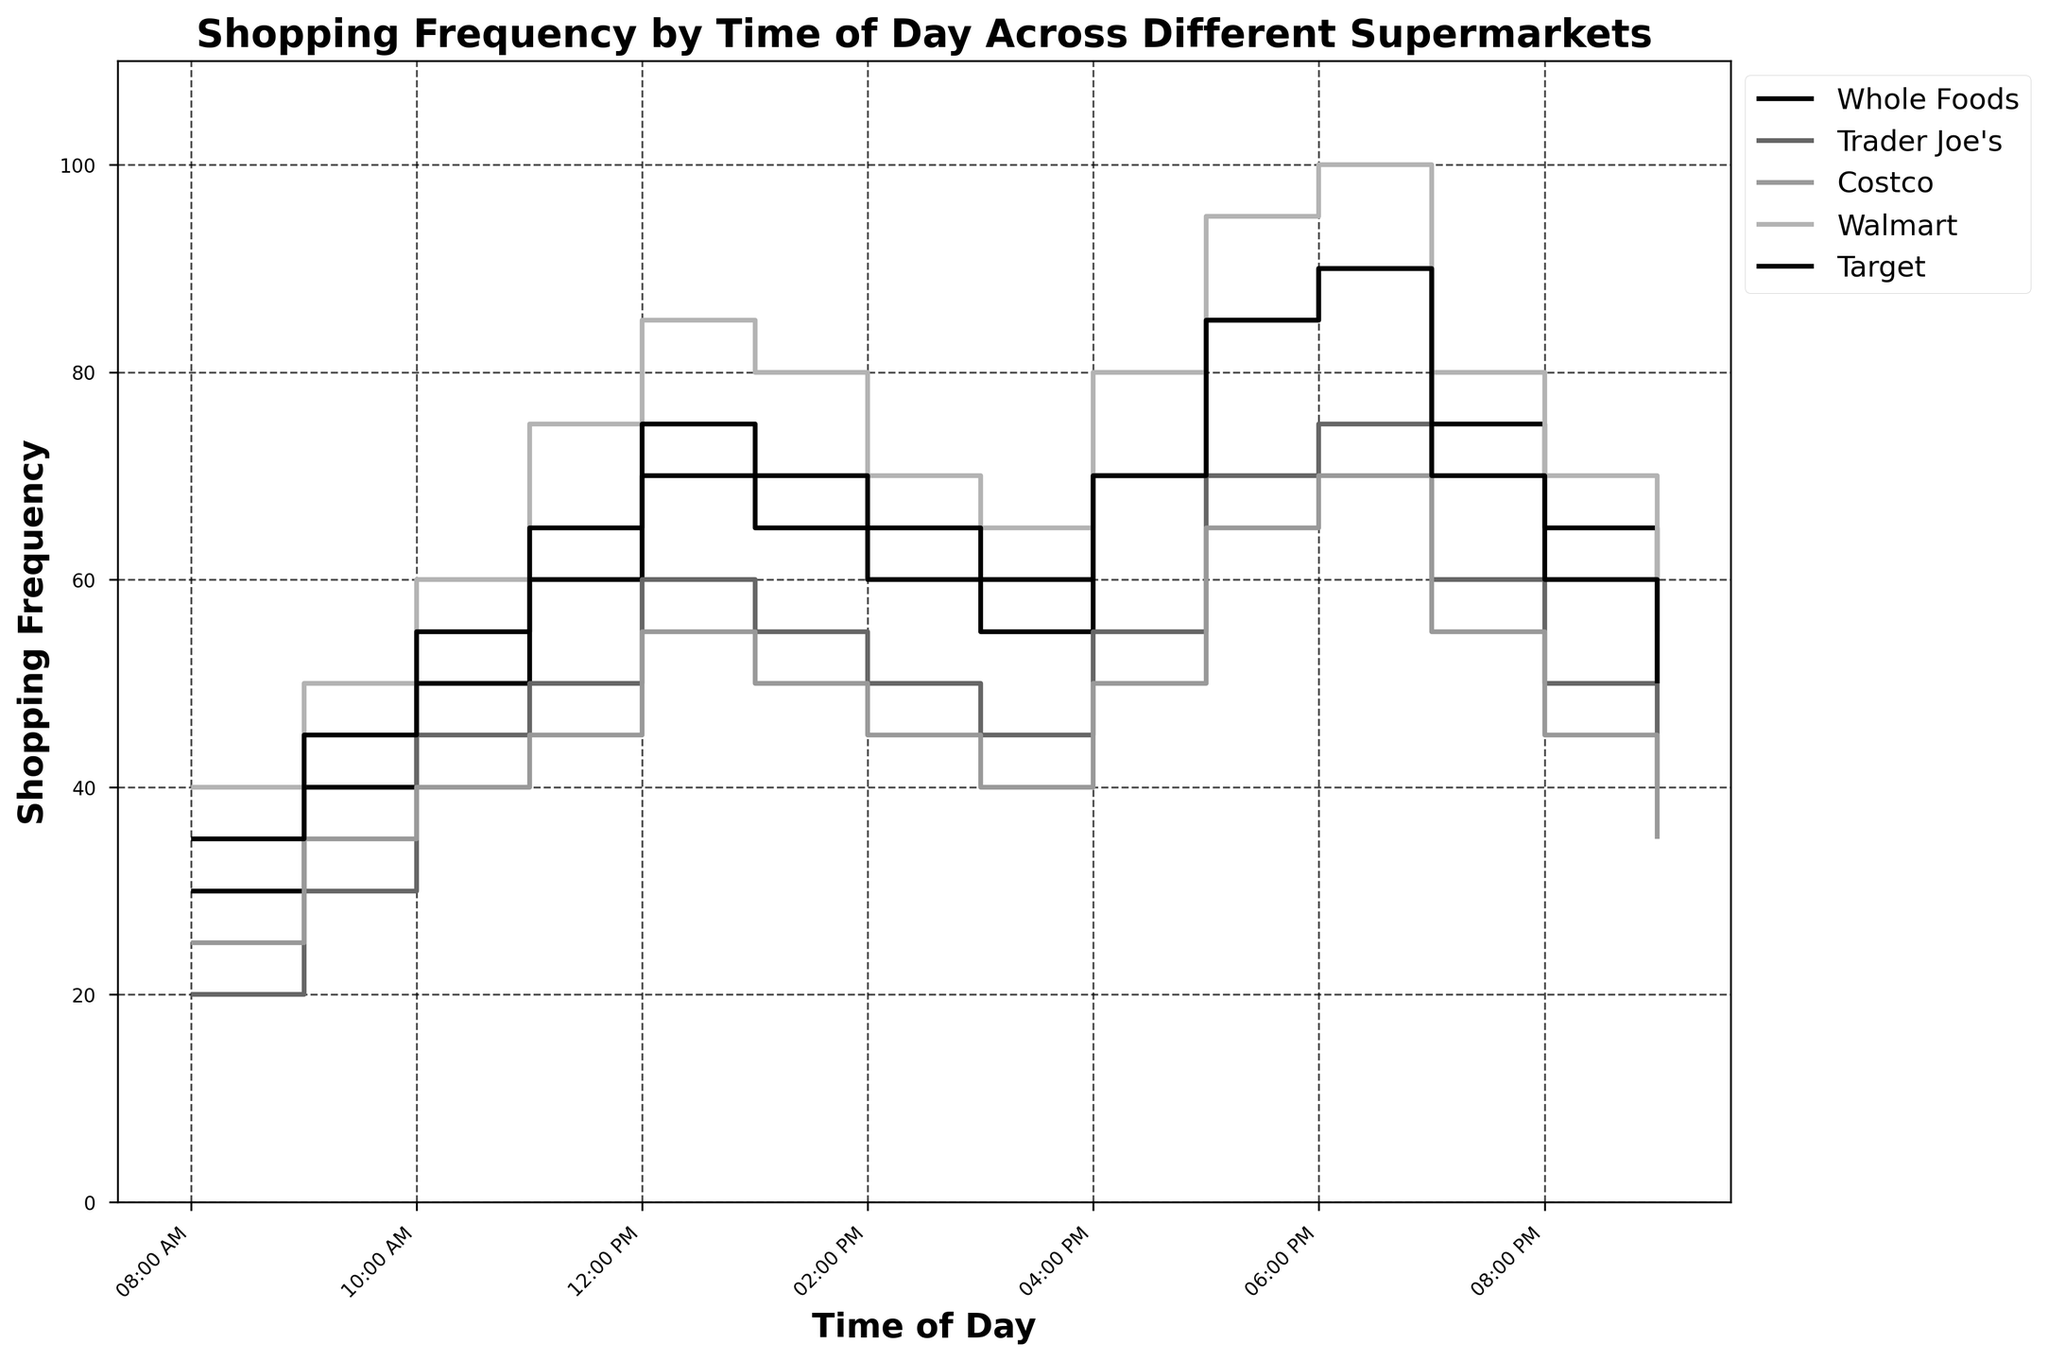What is the title of the figure? The title is located at the top of the figure. It is bold and larger in font size compared to other texts in the figure.
Answer: Shopping Frequency by Time of Day Across Different Supermarkets Which supermarket has the highest shopping frequency at 6:00 PM? Look at the vertical level corresponding to 6:00 PM on the x-axis. Identify which line (corresponding to a supermarket) is at the highest vertical position. This represents the highest frequency.
Answer: Walmart How many times does the shopping frequency at Trader Joe’s exceed 50? Look at the Trader Joe's line and count the number of points where the vertical level (y-axis) exceeds 50.
Answer: 4 times At what time does Whole Foods' shopping frequency peak? Examine the Whole Foods line and find the time point on the x-axis where it reaches its highest level.
Answer: 6:00 PM What's the difference in shopping frequency between Target and Costco at 8:00 AM? Find the points for Target and Costco at 8:00 AM on the x-axis. Subtract the frequency values of Costco from Target to get the difference.
Answer: 10 Which supermarket has the smallest change in shopping frequency between 3:00 PM and 4:00 PM? Calculate the change in frequency between 3:00 PM and 4:00 PM for all supermarkets by subtracting the frequency at 3:00 PM from that at 4:00 PM. Compare the changes and identify the smallest one.
Answer: Trader Joe's What is the average shopping frequency at noon for all supermarkets? Add the shopping frequency values at 12:00 PM for all supermarkets: Whole Foods, Trader Joe’s, Costco, Walmart, and Target. Divide the sum by the number of supermarkets (5) to calculate the average.
Answer: 69 During which two-hour time period is the increase in shopping frequency for Walmart the highest? Find the differences in Walmart's frequency between consecutive time intervals and identify the two-hour period with the largest increase.
Answer: 4:00 PM - 6:00 PM If the professional prefers off-peak hours, which time slot is the least crowded overall? Calculate the sum of frequencies for all supermarkets at each time point. Compare these sums to find the smallest one, indicating the least crowded period.
Answer: 9:00 PM 